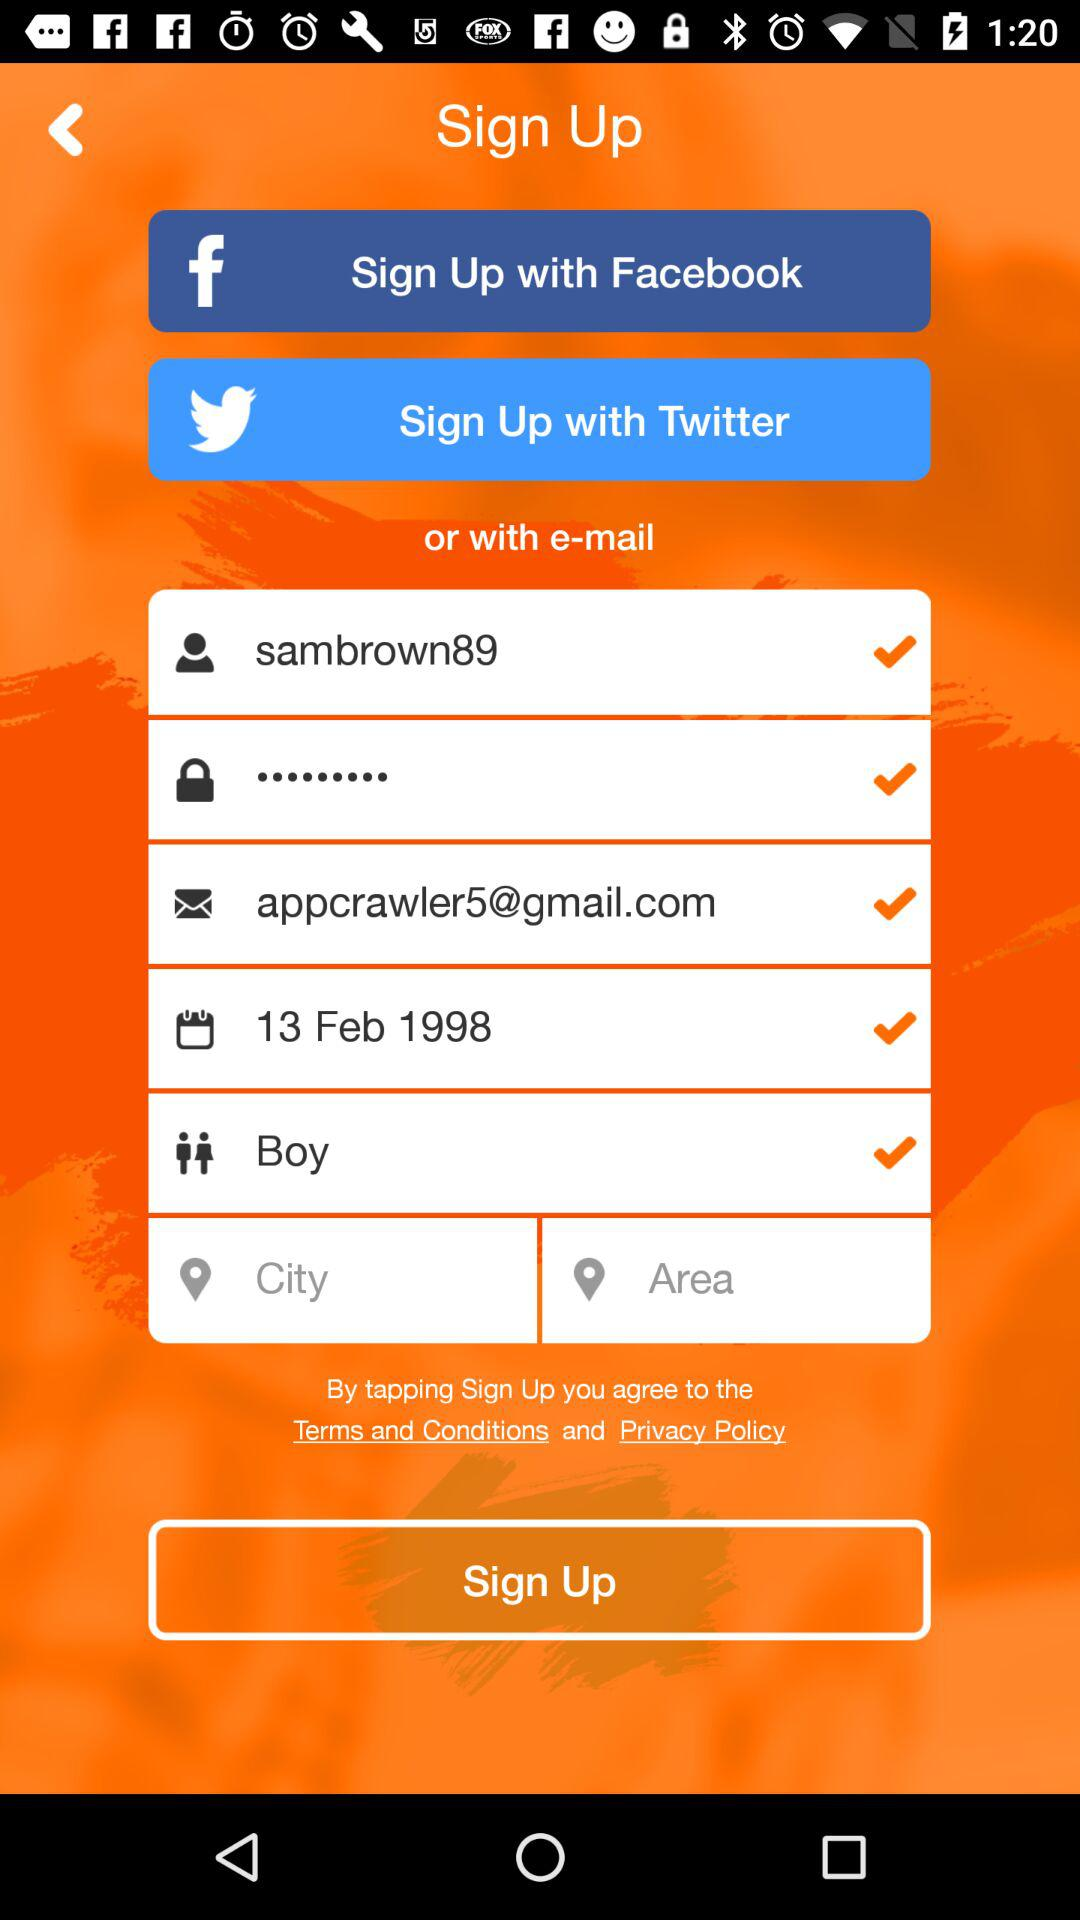What is the selected gender?
When the provided information is insufficient, respond with <no answer>. <no answer> 